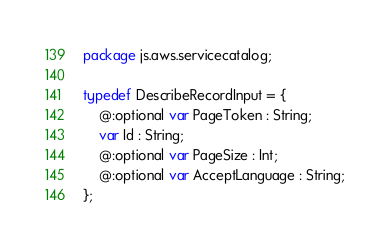<code> <loc_0><loc_0><loc_500><loc_500><_Haxe_>package js.aws.servicecatalog;

typedef DescribeRecordInput = {
    @:optional var PageToken : String;
    var Id : String;
    @:optional var PageSize : Int;
    @:optional var AcceptLanguage : String;
};
</code> 